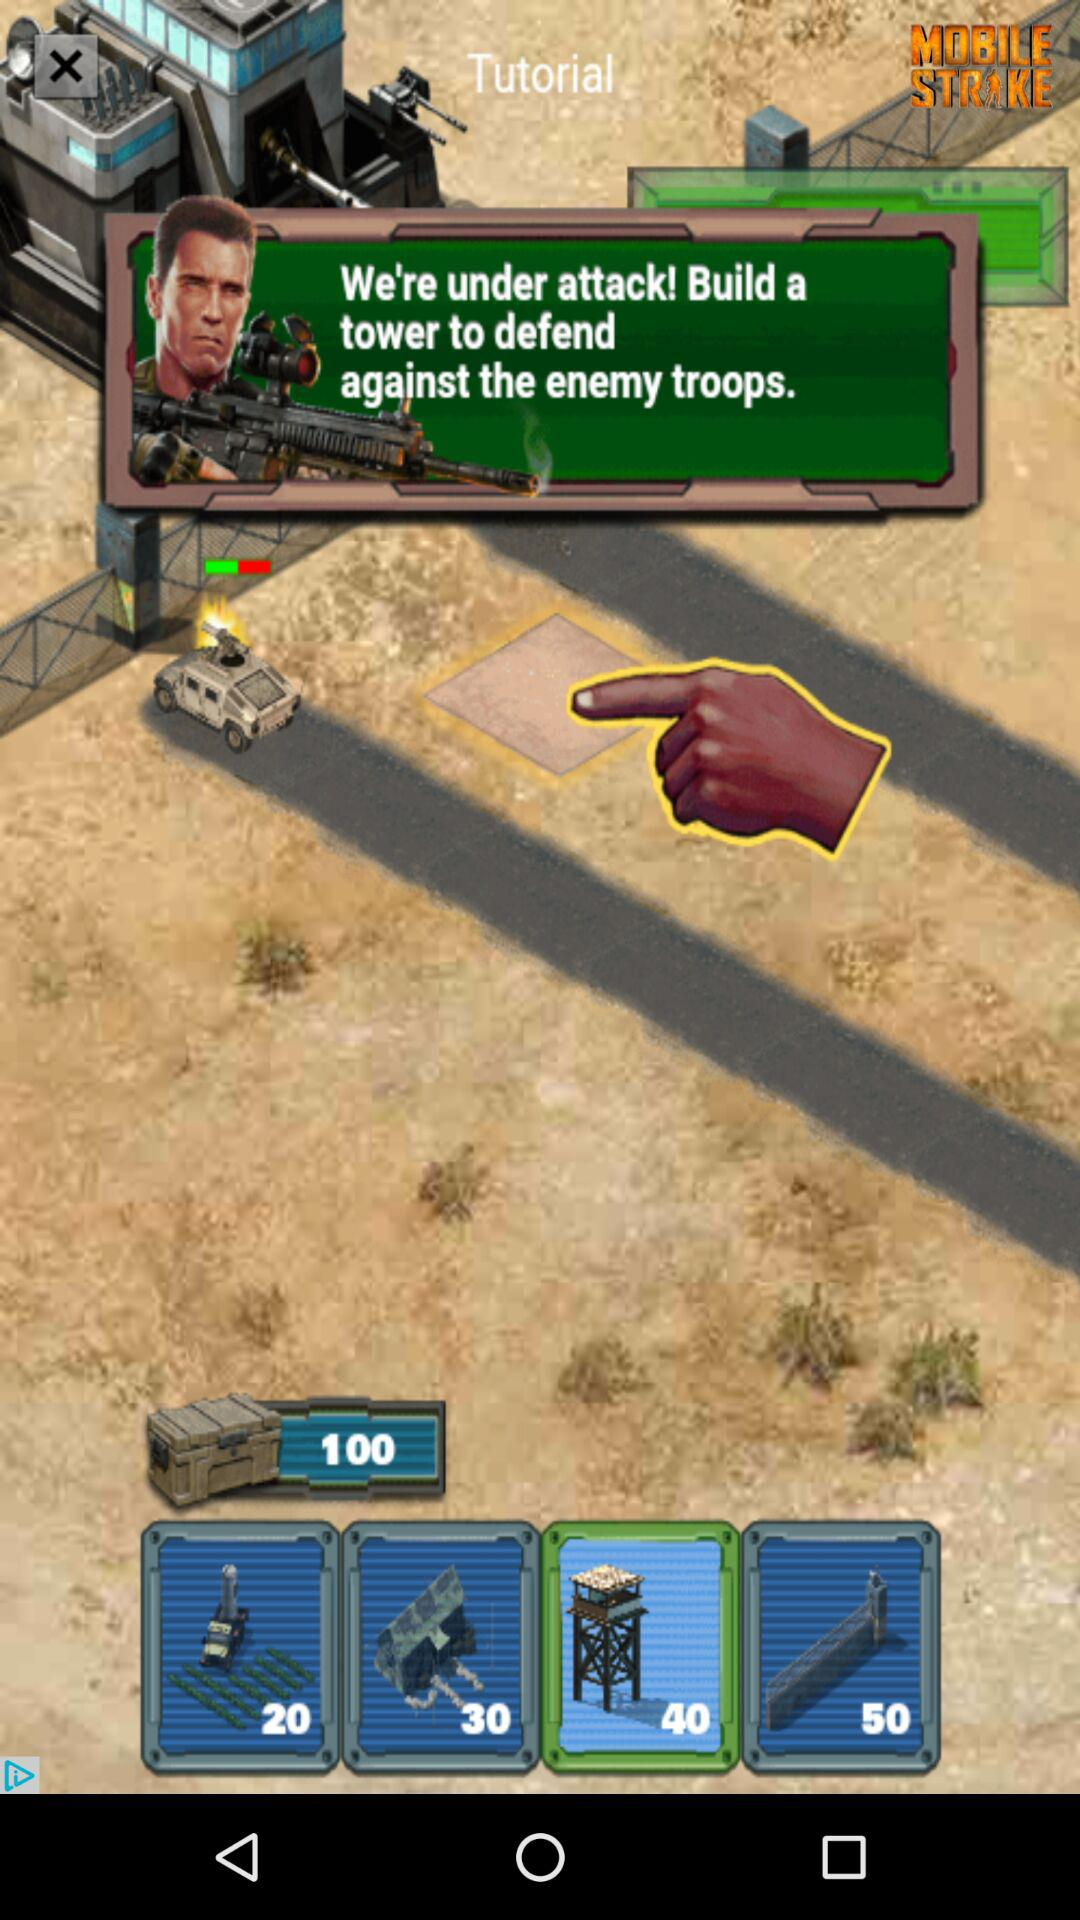How much more money is required to purchase the 50 point tower than the 20 point tower?
Answer the question using a single word or phrase. 30 